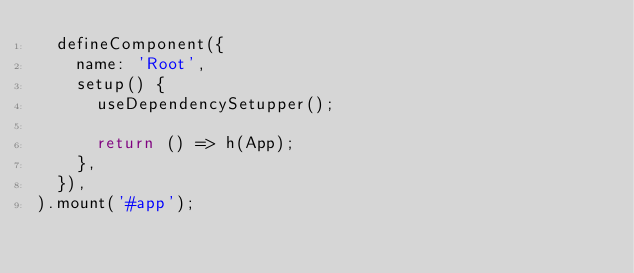Convert code to text. <code><loc_0><loc_0><loc_500><loc_500><_TypeScript_>  defineComponent({
    name: 'Root',
    setup() {
      useDependencySetupper();

      return () => h(App);
    },
  }),
).mount('#app');
</code> 